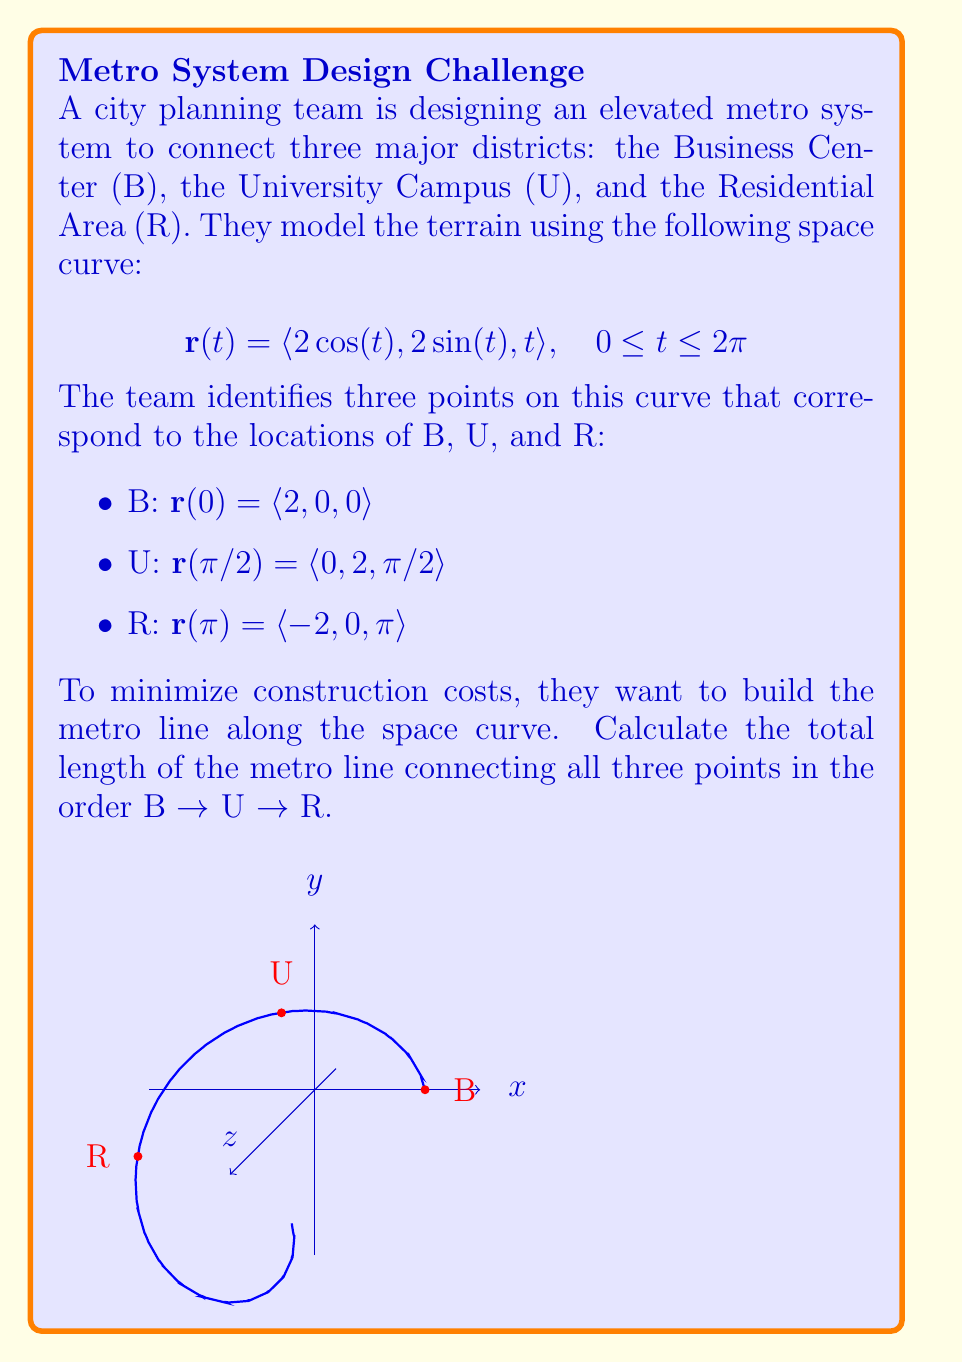Provide a solution to this math problem. To solve this problem, we need to calculate the arc length of the space curve between the given points. We'll do this in two steps: B to U, and U to R.

Step 1: Calculate the arc length formula
The arc length of a space curve from $t=a$ to $t=b$ is given by:

$$L = \int_a^b \sqrt{\left(\frac{dx}{dt}\right)^2 + \left(\frac{dy}{dt}\right)^2 + \left(\frac{dz}{dt}\right)^2} dt$$

For our curve $\mathbf{r}(t) = \langle 2\cos(t), 2\sin(t), t \rangle$, we have:

$$\frac{dx}{dt} = -2\sin(t)$$
$$\frac{dy}{dt} = 2\cos(t)$$
$$\frac{dz}{dt} = 1$$

Substituting these into the arc length formula:

$$L = \int_a^b \sqrt{(-2\sin(t))^2 + (2\cos(t))^2 + 1^2} dt$$
$$L = \int_a^b \sqrt{4\sin^2(t) + 4\cos^2(t) + 1} dt$$
$$L = \int_a^b \sqrt{4(\sin^2(t) + \cos^2(t)) + 1} dt$$
$$L = \int_a^b \sqrt{5} dt$$

Step 2: Calculate the length from B to U
From B to U, $t$ goes from 0 to $\pi/2$. So:

$$L_{BU} = \int_0^{\pi/2} \sqrt{5} dt = \sqrt{5} \cdot \frac{\pi}{2}$$

Step 3: Calculate the length from U to R
From U to R, $t$ goes from $\pi/2$ to $\pi$. So:

$$L_{UR} = \int_{\pi/2}^{\pi} \sqrt{5} dt = \sqrt{5} \cdot \frac{\pi}{2}$$

Step 4: Sum the lengths
The total length is the sum of these two segments:

$$L_{total} = L_{BU} + L_{UR} = \sqrt{5} \cdot \frac{\pi}{2} + \sqrt{5} \cdot \frac{\pi}{2} = \sqrt{5} \pi$$
Answer: $\sqrt{5} \pi$ 